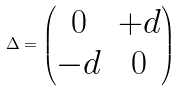<formula> <loc_0><loc_0><loc_500><loc_500>\Delta = \begin{pmatrix} 0 & + d \\ - d & 0 \end{pmatrix}</formula> 